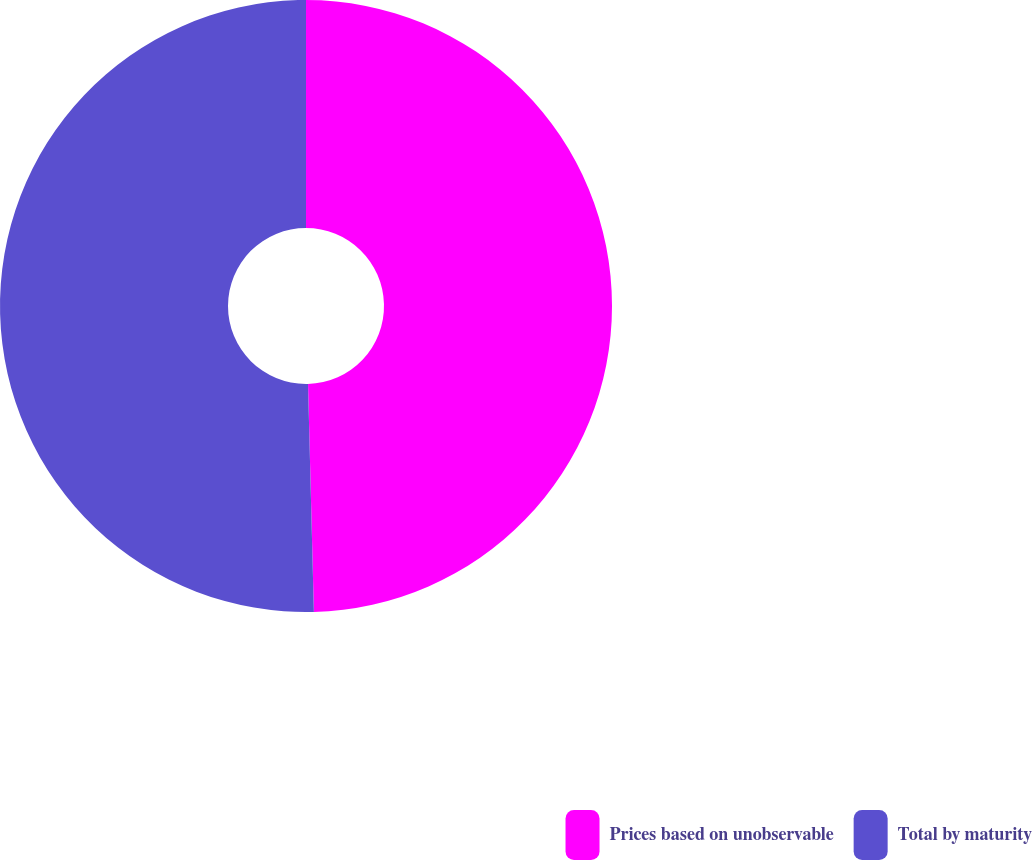Convert chart. <chart><loc_0><loc_0><loc_500><loc_500><pie_chart><fcel>Prices based on unobservable<fcel>Total by maturity<nl><fcel>49.59%<fcel>50.41%<nl></chart> 